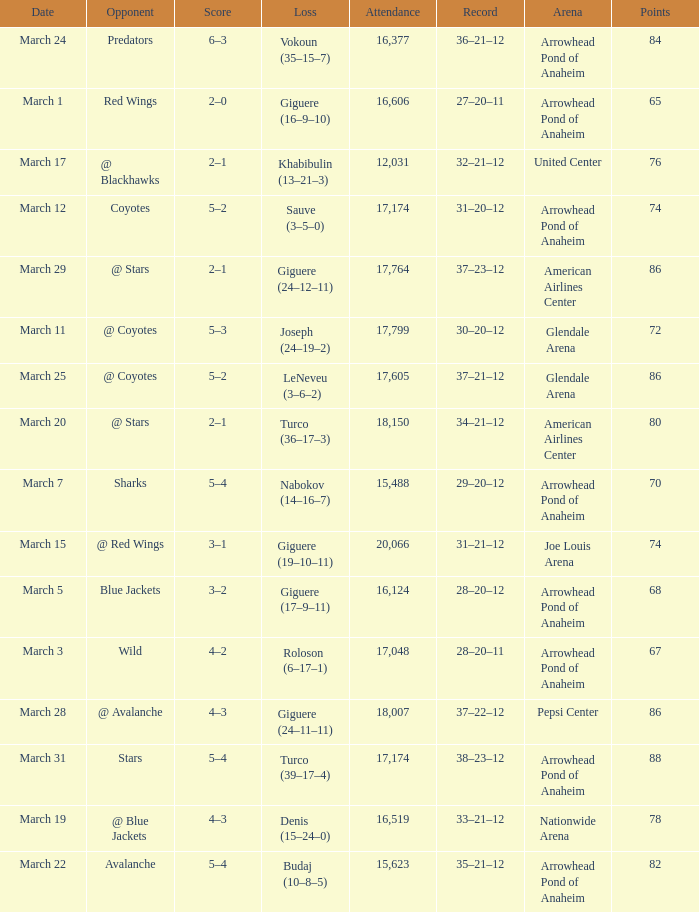What is the Attendance at Joe Louis Arena? 20066.0. 